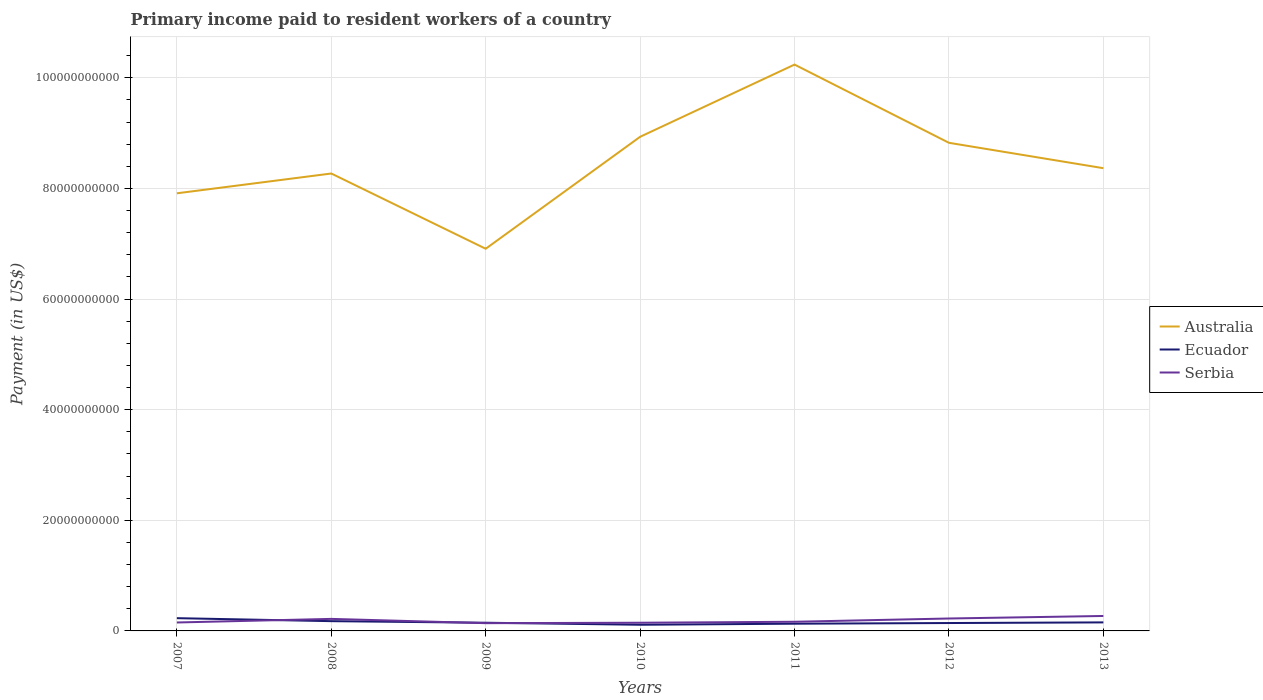How many different coloured lines are there?
Give a very brief answer. 3. Is the number of lines equal to the number of legend labels?
Provide a short and direct response. Yes. Across all years, what is the maximum amount paid to workers in Australia?
Offer a terse response. 6.91e+1. In which year was the amount paid to workers in Serbia maximum?
Ensure brevity in your answer.  2009. What is the total amount paid to workers in Ecuador in the graph?
Keep it short and to the point. -4.25e+08. What is the difference between the highest and the second highest amount paid to workers in Australia?
Your answer should be compact. 3.33e+1. What is the difference between the highest and the lowest amount paid to workers in Australia?
Your answer should be very brief. 3. Are the values on the major ticks of Y-axis written in scientific E-notation?
Ensure brevity in your answer.  No. Does the graph contain grids?
Give a very brief answer. Yes. How many legend labels are there?
Offer a very short reply. 3. How are the legend labels stacked?
Ensure brevity in your answer.  Vertical. What is the title of the graph?
Offer a very short reply. Primary income paid to resident workers of a country. What is the label or title of the Y-axis?
Offer a very short reply. Payment (in US$). What is the Payment (in US$) in Australia in 2007?
Your response must be concise. 7.91e+1. What is the Payment (in US$) in Ecuador in 2007?
Keep it short and to the point. 2.31e+09. What is the Payment (in US$) of Serbia in 2007?
Your response must be concise. 1.53e+09. What is the Payment (in US$) of Australia in 2008?
Your answer should be compact. 8.27e+1. What is the Payment (in US$) of Ecuador in 2008?
Give a very brief answer. 1.77e+09. What is the Payment (in US$) in Serbia in 2008?
Your answer should be compact. 2.18e+09. What is the Payment (in US$) of Australia in 2009?
Your answer should be compact. 6.91e+1. What is the Payment (in US$) in Ecuador in 2009?
Offer a very short reply. 1.48e+09. What is the Payment (in US$) in Serbia in 2009?
Provide a short and direct response. 1.40e+09. What is the Payment (in US$) of Australia in 2010?
Your answer should be compact. 8.93e+1. What is the Payment (in US$) in Ecuador in 2010?
Your answer should be compact. 1.12e+09. What is the Payment (in US$) in Serbia in 2010?
Keep it short and to the point. 1.48e+09. What is the Payment (in US$) in Australia in 2011?
Provide a short and direct response. 1.02e+11. What is the Payment (in US$) of Ecuador in 2011?
Provide a short and direct response. 1.30e+09. What is the Payment (in US$) of Serbia in 2011?
Ensure brevity in your answer.  1.65e+09. What is the Payment (in US$) of Australia in 2012?
Your answer should be compact. 8.83e+1. What is the Payment (in US$) of Ecuador in 2012?
Offer a terse response. 1.43e+09. What is the Payment (in US$) in Serbia in 2012?
Ensure brevity in your answer.  2.24e+09. What is the Payment (in US$) of Australia in 2013?
Provide a short and direct response. 8.37e+1. What is the Payment (in US$) in Ecuador in 2013?
Provide a succinct answer. 1.54e+09. What is the Payment (in US$) in Serbia in 2013?
Offer a terse response. 2.70e+09. Across all years, what is the maximum Payment (in US$) of Australia?
Provide a short and direct response. 1.02e+11. Across all years, what is the maximum Payment (in US$) in Ecuador?
Your answer should be very brief. 2.31e+09. Across all years, what is the maximum Payment (in US$) of Serbia?
Keep it short and to the point. 2.70e+09. Across all years, what is the minimum Payment (in US$) of Australia?
Provide a short and direct response. 6.91e+1. Across all years, what is the minimum Payment (in US$) in Ecuador?
Your response must be concise. 1.12e+09. Across all years, what is the minimum Payment (in US$) of Serbia?
Offer a terse response. 1.40e+09. What is the total Payment (in US$) of Australia in the graph?
Make the answer very short. 5.95e+11. What is the total Payment (in US$) in Ecuador in the graph?
Offer a terse response. 1.09e+1. What is the total Payment (in US$) in Serbia in the graph?
Provide a succinct answer. 1.32e+1. What is the difference between the Payment (in US$) of Australia in 2007 and that in 2008?
Make the answer very short. -3.58e+09. What is the difference between the Payment (in US$) in Ecuador in 2007 and that in 2008?
Give a very brief answer. 5.40e+08. What is the difference between the Payment (in US$) in Serbia in 2007 and that in 2008?
Ensure brevity in your answer.  -6.50e+08. What is the difference between the Payment (in US$) in Australia in 2007 and that in 2009?
Offer a terse response. 1.00e+1. What is the difference between the Payment (in US$) of Ecuador in 2007 and that in 2009?
Offer a very short reply. 8.27e+08. What is the difference between the Payment (in US$) in Serbia in 2007 and that in 2009?
Make the answer very short. 1.25e+08. What is the difference between the Payment (in US$) of Australia in 2007 and that in 2010?
Your answer should be very brief. -1.02e+1. What is the difference between the Payment (in US$) of Ecuador in 2007 and that in 2010?
Offer a terse response. 1.19e+09. What is the difference between the Payment (in US$) in Serbia in 2007 and that in 2010?
Provide a short and direct response. 4.60e+07. What is the difference between the Payment (in US$) of Australia in 2007 and that in 2011?
Make the answer very short. -2.33e+1. What is the difference between the Payment (in US$) of Ecuador in 2007 and that in 2011?
Offer a very short reply. 1.00e+09. What is the difference between the Payment (in US$) of Serbia in 2007 and that in 2011?
Your response must be concise. -1.29e+08. What is the difference between the Payment (in US$) of Australia in 2007 and that in 2012?
Provide a short and direct response. -9.13e+09. What is the difference between the Payment (in US$) of Ecuador in 2007 and that in 2012?
Ensure brevity in your answer.  8.78e+08. What is the difference between the Payment (in US$) in Serbia in 2007 and that in 2012?
Offer a terse response. -7.19e+08. What is the difference between the Payment (in US$) in Australia in 2007 and that in 2013?
Make the answer very short. -4.54e+09. What is the difference between the Payment (in US$) of Ecuador in 2007 and that in 2013?
Keep it short and to the point. 7.64e+08. What is the difference between the Payment (in US$) in Serbia in 2007 and that in 2013?
Offer a terse response. -1.18e+09. What is the difference between the Payment (in US$) in Australia in 2008 and that in 2009?
Ensure brevity in your answer.  1.36e+1. What is the difference between the Payment (in US$) of Ecuador in 2008 and that in 2009?
Give a very brief answer. 2.87e+08. What is the difference between the Payment (in US$) of Serbia in 2008 and that in 2009?
Your answer should be compact. 7.74e+08. What is the difference between the Payment (in US$) in Australia in 2008 and that in 2010?
Give a very brief answer. -6.64e+09. What is the difference between the Payment (in US$) of Ecuador in 2008 and that in 2010?
Give a very brief answer. 6.50e+08. What is the difference between the Payment (in US$) in Serbia in 2008 and that in 2010?
Provide a succinct answer. 6.96e+08. What is the difference between the Payment (in US$) of Australia in 2008 and that in 2011?
Your answer should be very brief. -1.97e+1. What is the difference between the Payment (in US$) of Ecuador in 2008 and that in 2011?
Provide a succinct answer. 4.61e+08. What is the difference between the Payment (in US$) of Serbia in 2008 and that in 2011?
Your response must be concise. 5.21e+08. What is the difference between the Payment (in US$) in Australia in 2008 and that in 2012?
Offer a terse response. -5.55e+09. What is the difference between the Payment (in US$) in Ecuador in 2008 and that in 2012?
Give a very brief answer. 3.38e+08. What is the difference between the Payment (in US$) in Serbia in 2008 and that in 2012?
Give a very brief answer. -6.90e+07. What is the difference between the Payment (in US$) in Australia in 2008 and that in 2013?
Give a very brief answer. -9.62e+08. What is the difference between the Payment (in US$) of Ecuador in 2008 and that in 2013?
Keep it short and to the point. 2.25e+08. What is the difference between the Payment (in US$) in Serbia in 2008 and that in 2013?
Your answer should be very brief. -5.28e+08. What is the difference between the Payment (in US$) of Australia in 2009 and that in 2010?
Your answer should be compact. -2.02e+1. What is the difference between the Payment (in US$) in Ecuador in 2009 and that in 2010?
Provide a succinct answer. 3.63e+08. What is the difference between the Payment (in US$) in Serbia in 2009 and that in 2010?
Make the answer very short. -7.85e+07. What is the difference between the Payment (in US$) in Australia in 2009 and that in 2011?
Offer a very short reply. -3.33e+1. What is the difference between the Payment (in US$) of Ecuador in 2009 and that in 2011?
Ensure brevity in your answer.  1.74e+08. What is the difference between the Payment (in US$) of Serbia in 2009 and that in 2011?
Provide a short and direct response. -2.54e+08. What is the difference between the Payment (in US$) of Australia in 2009 and that in 2012?
Offer a very short reply. -1.92e+1. What is the difference between the Payment (in US$) in Ecuador in 2009 and that in 2012?
Your response must be concise. 5.15e+07. What is the difference between the Payment (in US$) in Serbia in 2009 and that in 2012?
Your answer should be very brief. -8.43e+08. What is the difference between the Payment (in US$) in Australia in 2009 and that in 2013?
Make the answer very short. -1.46e+1. What is the difference between the Payment (in US$) in Ecuador in 2009 and that in 2013?
Offer a terse response. -6.24e+07. What is the difference between the Payment (in US$) in Serbia in 2009 and that in 2013?
Your response must be concise. -1.30e+09. What is the difference between the Payment (in US$) of Australia in 2010 and that in 2011?
Provide a short and direct response. -1.31e+1. What is the difference between the Payment (in US$) in Ecuador in 2010 and that in 2011?
Your answer should be very brief. -1.88e+08. What is the difference between the Payment (in US$) of Serbia in 2010 and that in 2011?
Offer a very short reply. -1.75e+08. What is the difference between the Payment (in US$) of Australia in 2010 and that in 2012?
Your response must be concise. 1.09e+09. What is the difference between the Payment (in US$) in Ecuador in 2010 and that in 2012?
Give a very brief answer. -3.11e+08. What is the difference between the Payment (in US$) of Serbia in 2010 and that in 2012?
Offer a very short reply. -7.65e+08. What is the difference between the Payment (in US$) in Australia in 2010 and that in 2013?
Your response must be concise. 5.68e+09. What is the difference between the Payment (in US$) in Ecuador in 2010 and that in 2013?
Ensure brevity in your answer.  -4.25e+08. What is the difference between the Payment (in US$) of Serbia in 2010 and that in 2013?
Keep it short and to the point. -1.22e+09. What is the difference between the Payment (in US$) of Australia in 2011 and that in 2012?
Offer a very short reply. 1.41e+1. What is the difference between the Payment (in US$) in Ecuador in 2011 and that in 2012?
Offer a very short reply. -1.23e+08. What is the difference between the Payment (in US$) of Serbia in 2011 and that in 2012?
Offer a very short reply. -5.90e+08. What is the difference between the Payment (in US$) of Australia in 2011 and that in 2013?
Keep it short and to the point. 1.87e+1. What is the difference between the Payment (in US$) in Ecuador in 2011 and that in 2013?
Provide a succinct answer. -2.37e+08. What is the difference between the Payment (in US$) in Serbia in 2011 and that in 2013?
Make the answer very short. -1.05e+09. What is the difference between the Payment (in US$) in Australia in 2012 and that in 2013?
Your answer should be very brief. 4.59e+09. What is the difference between the Payment (in US$) in Ecuador in 2012 and that in 2013?
Make the answer very short. -1.14e+08. What is the difference between the Payment (in US$) of Serbia in 2012 and that in 2013?
Provide a short and direct response. -4.59e+08. What is the difference between the Payment (in US$) in Australia in 2007 and the Payment (in US$) in Ecuador in 2008?
Provide a succinct answer. 7.74e+1. What is the difference between the Payment (in US$) of Australia in 2007 and the Payment (in US$) of Serbia in 2008?
Offer a very short reply. 7.69e+1. What is the difference between the Payment (in US$) of Ecuador in 2007 and the Payment (in US$) of Serbia in 2008?
Offer a very short reply. 1.30e+08. What is the difference between the Payment (in US$) in Australia in 2007 and the Payment (in US$) in Ecuador in 2009?
Offer a terse response. 7.76e+1. What is the difference between the Payment (in US$) of Australia in 2007 and the Payment (in US$) of Serbia in 2009?
Offer a very short reply. 7.77e+1. What is the difference between the Payment (in US$) in Ecuador in 2007 and the Payment (in US$) in Serbia in 2009?
Your answer should be compact. 9.04e+08. What is the difference between the Payment (in US$) in Australia in 2007 and the Payment (in US$) in Ecuador in 2010?
Provide a succinct answer. 7.80e+1. What is the difference between the Payment (in US$) of Australia in 2007 and the Payment (in US$) of Serbia in 2010?
Keep it short and to the point. 7.76e+1. What is the difference between the Payment (in US$) of Ecuador in 2007 and the Payment (in US$) of Serbia in 2010?
Provide a short and direct response. 8.26e+08. What is the difference between the Payment (in US$) of Australia in 2007 and the Payment (in US$) of Ecuador in 2011?
Offer a terse response. 7.78e+1. What is the difference between the Payment (in US$) of Australia in 2007 and the Payment (in US$) of Serbia in 2011?
Your response must be concise. 7.75e+1. What is the difference between the Payment (in US$) in Ecuador in 2007 and the Payment (in US$) in Serbia in 2011?
Your answer should be compact. 6.51e+08. What is the difference between the Payment (in US$) of Australia in 2007 and the Payment (in US$) of Ecuador in 2012?
Provide a succinct answer. 7.77e+1. What is the difference between the Payment (in US$) of Australia in 2007 and the Payment (in US$) of Serbia in 2012?
Your answer should be very brief. 7.69e+1. What is the difference between the Payment (in US$) of Ecuador in 2007 and the Payment (in US$) of Serbia in 2012?
Your answer should be compact. 6.09e+07. What is the difference between the Payment (in US$) of Australia in 2007 and the Payment (in US$) of Ecuador in 2013?
Keep it short and to the point. 7.76e+1. What is the difference between the Payment (in US$) of Australia in 2007 and the Payment (in US$) of Serbia in 2013?
Ensure brevity in your answer.  7.64e+1. What is the difference between the Payment (in US$) in Ecuador in 2007 and the Payment (in US$) in Serbia in 2013?
Offer a very short reply. -3.98e+08. What is the difference between the Payment (in US$) of Australia in 2008 and the Payment (in US$) of Ecuador in 2009?
Your answer should be very brief. 8.12e+1. What is the difference between the Payment (in US$) in Australia in 2008 and the Payment (in US$) in Serbia in 2009?
Ensure brevity in your answer.  8.13e+1. What is the difference between the Payment (in US$) in Ecuador in 2008 and the Payment (in US$) in Serbia in 2009?
Ensure brevity in your answer.  3.65e+08. What is the difference between the Payment (in US$) of Australia in 2008 and the Payment (in US$) of Ecuador in 2010?
Offer a very short reply. 8.16e+1. What is the difference between the Payment (in US$) in Australia in 2008 and the Payment (in US$) in Serbia in 2010?
Keep it short and to the point. 8.12e+1. What is the difference between the Payment (in US$) of Ecuador in 2008 and the Payment (in US$) of Serbia in 2010?
Offer a terse response. 2.86e+08. What is the difference between the Payment (in US$) of Australia in 2008 and the Payment (in US$) of Ecuador in 2011?
Offer a very short reply. 8.14e+1. What is the difference between the Payment (in US$) of Australia in 2008 and the Payment (in US$) of Serbia in 2011?
Provide a succinct answer. 8.11e+1. What is the difference between the Payment (in US$) in Ecuador in 2008 and the Payment (in US$) in Serbia in 2011?
Your answer should be very brief. 1.11e+08. What is the difference between the Payment (in US$) in Australia in 2008 and the Payment (in US$) in Ecuador in 2012?
Ensure brevity in your answer.  8.13e+1. What is the difference between the Payment (in US$) in Australia in 2008 and the Payment (in US$) in Serbia in 2012?
Give a very brief answer. 8.05e+1. What is the difference between the Payment (in US$) in Ecuador in 2008 and the Payment (in US$) in Serbia in 2012?
Give a very brief answer. -4.79e+08. What is the difference between the Payment (in US$) in Australia in 2008 and the Payment (in US$) in Ecuador in 2013?
Give a very brief answer. 8.12e+1. What is the difference between the Payment (in US$) of Australia in 2008 and the Payment (in US$) of Serbia in 2013?
Offer a terse response. 8.00e+1. What is the difference between the Payment (in US$) in Ecuador in 2008 and the Payment (in US$) in Serbia in 2013?
Keep it short and to the point. -9.37e+08. What is the difference between the Payment (in US$) in Australia in 2009 and the Payment (in US$) in Ecuador in 2010?
Make the answer very short. 6.80e+1. What is the difference between the Payment (in US$) in Australia in 2009 and the Payment (in US$) in Serbia in 2010?
Ensure brevity in your answer.  6.76e+1. What is the difference between the Payment (in US$) in Ecuador in 2009 and the Payment (in US$) in Serbia in 2010?
Keep it short and to the point. -9.51e+05. What is the difference between the Payment (in US$) of Australia in 2009 and the Payment (in US$) of Ecuador in 2011?
Provide a succinct answer. 6.78e+1. What is the difference between the Payment (in US$) in Australia in 2009 and the Payment (in US$) in Serbia in 2011?
Your answer should be compact. 6.74e+1. What is the difference between the Payment (in US$) in Ecuador in 2009 and the Payment (in US$) in Serbia in 2011?
Make the answer very short. -1.76e+08. What is the difference between the Payment (in US$) in Australia in 2009 and the Payment (in US$) in Ecuador in 2012?
Provide a succinct answer. 6.77e+1. What is the difference between the Payment (in US$) in Australia in 2009 and the Payment (in US$) in Serbia in 2012?
Your answer should be compact. 6.69e+1. What is the difference between the Payment (in US$) of Ecuador in 2009 and the Payment (in US$) of Serbia in 2012?
Ensure brevity in your answer.  -7.66e+08. What is the difference between the Payment (in US$) of Australia in 2009 and the Payment (in US$) of Ecuador in 2013?
Offer a very short reply. 6.76e+1. What is the difference between the Payment (in US$) in Australia in 2009 and the Payment (in US$) in Serbia in 2013?
Provide a succinct answer. 6.64e+1. What is the difference between the Payment (in US$) in Ecuador in 2009 and the Payment (in US$) in Serbia in 2013?
Ensure brevity in your answer.  -1.22e+09. What is the difference between the Payment (in US$) of Australia in 2010 and the Payment (in US$) of Ecuador in 2011?
Provide a succinct answer. 8.80e+1. What is the difference between the Payment (in US$) in Australia in 2010 and the Payment (in US$) in Serbia in 2011?
Make the answer very short. 8.77e+1. What is the difference between the Payment (in US$) of Ecuador in 2010 and the Payment (in US$) of Serbia in 2011?
Offer a very short reply. -5.39e+08. What is the difference between the Payment (in US$) of Australia in 2010 and the Payment (in US$) of Ecuador in 2012?
Offer a very short reply. 8.79e+1. What is the difference between the Payment (in US$) in Australia in 2010 and the Payment (in US$) in Serbia in 2012?
Provide a succinct answer. 8.71e+1. What is the difference between the Payment (in US$) in Ecuador in 2010 and the Payment (in US$) in Serbia in 2012?
Provide a short and direct response. -1.13e+09. What is the difference between the Payment (in US$) of Australia in 2010 and the Payment (in US$) of Ecuador in 2013?
Your answer should be compact. 8.78e+1. What is the difference between the Payment (in US$) of Australia in 2010 and the Payment (in US$) of Serbia in 2013?
Your answer should be compact. 8.66e+1. What is the difference between the Payment (in US$) of Ecuador in 2010 and the Payment (in US$) of Serbia in 2013?
Provide a succinct answer. -1.59e+09. What is the difference between the Payment (in US$) in Australia in 2011 and the Payment (in US$) in Ecuador in 2012?
Ensure brevity in your answer.  1.01e+11. What is the difference between the Payment (in US$) of Australia in 2011 and the Payment (in US$) of Serbia in 2012?
Ensure brevity in your answer.  1.00e+11. What is the difference between the Payment (in US$) of Ecuador in 2011 and the Payment (in US$) of Serbia in 2012?
Provide a succinct answer. -9.40e+08. What is the difference between the Payment (in US$) in Australia in 2011 and the Payment (in US$) in Ecuador in 2013?
Provide a short and direct response. 1.01e+11. What is the difference between the Payment (in US$) in Australia in 2011 and the Payment (in US$) in Serbia in 2013?
Offer a terse response. 9.97e+1. What is the difference between the Payment (in US$) in Ecuador in 2011 and the Payment (in US$) in Serbia in 2013?
Ensure brevity in your answer.  -1.40e+09. What is the difference between the Payment (in US$) in Australia in 2012 and the Payment (in US$) in Ecuador in 2013?
Make the answer very short. 8.67e+1. What is the difference between the Payment (in US$) in Australia in 2012 and the Payment (in US$) in Serbia in 2013?
Give a very brief answer. 8.56e+1. What is the difference between the Payment (in US$) in Ecuador in 2012 and the Payment (in US$) in Serbia in 2013?
Offer a very short reply. -1.28e+09. What is the average Payment (in US$) in Australia per year?
Your answer should be compact. 8.49e+1. What is the average Payment (in US$) of Ecuador per year?
Keep it short and to the point. 1.56e+09. What is the average Payment (in US$) in Serbia per year?
Make the answer very short. 1.88e+09. In the year 2007, what is the difference between the Payment (in US$) of Australia and Payment (in US$) of Ecuador?
Provide a succinct answer. 7.68e+1. In the year 2007, what is the difference between the Payment (in US$) of Australia and Payment (in US$) of Serbia?
Provide a short and direct response. 7.76e+1. In the year 2007, what is the difference between the Payment (in US$) of Ecuador and Payment (in US$) of Serbia?
Your answer should be very brief. 7.80e+08. In the year 2008, what is the difference between the Payment (in US$) of Australia and Payment (in US$) of Ecuador?
Provide a short and direct response. 8.09e+1. In the year 2008, what is the difference between the Payment (in US$) of Australia and Payment (in US$) of Serbia?
Your answer should be very brief. 8.05e+1. In the year 2008, what is the difference between the Payment (in US$) in Ecuador and Payment (in US$) in Serbia?
Ensure brevity in your answer.  -4.10e+08. In the year 2009, what is the difference between the Payment (in US$) in Australia and Payment (in US$) in Ecuador?
Your answer should be very brief. 6.76e+1. In the year 2009, what is the difference between the Payment (in US$) in Australia and Payment (in US$) in Serbia?
Your response must be concise. 6.77e+1. In the year 2009, what is the difference between the Payment (in US$) in Ecuador and Payment (in US$) in Serbia?
Your response must be concise. 7.76e+07. In the year 2010, what is the difference between the Payment (in US$) in Australia and Payment (in US$) in Ecuador?
Ensure brevity in your answer.  8.82e+1. In the year 2010, what is the difference between the Payment (in US$) in Australia and Payment (in US$) in Serbia?
Offer a terse response. 8.79e+1. In the year 2010, what is the difference between the Payment (in US$) in Ecuador and Payment (in US$) in Serbia?
Your answer should be very brief. -3.64e+08. In the year 2011, what is the difference between the Payment (in US$) of Australia and Payment (in US$) of Ecuador?
Keep it short and to the point. 1.01e+11. In the year 2011, what is the difference between the Payment (in US$) of Australia and Payment (in US$) of Serbia?
Your response must be concise. 1.01e+11. In the year 2011, what is the difference between the Payment (in US$) in Ecuador and Payment (in US$) in Serbia?
Ensure brevity in your answer.  -3.50e+08. In the year 2012, what is the difference between the Payment (in US$) of Australia and Payment (in US$) of Ecuador?
Offer a very short reply. 8.68e+1. In the year 2012, what is the difference between the Payment (in US$) of Australia and Payment (in US$) of Serbia?
Provide a short and direct response. 8.60e+1. In the year 2012, what is the difference between the Payment (in US$) of Ecuador and Payment (in US$) of Serbia?
Offer a terse response. -8.17e+08. In the year 2013, what is the difference between the Payment (in US$) in Australia and Payment (in US$) in Ecuador?
Provide a short and direct response. 8.21e+1. In the year 2013, what is the difference between the Payment (in US$) of Australia and Payment (in US$) of Serbia?
Offer a terse response. 8.10e+1. In the year 2013, what is the difference between the Payment (in US$) in Ecuador and Payment (in US$) in Serbia?
Give a very brief answer. -1.16e+09. What is the ratio of the Payment (in US$) in Australia in 2007 to that in 2008?
Your answer should be compact. 0.96. What is the ratio of the Payment (in US$) of Ecuador in 2007 to that in 2008?
Make the answer very short. 1.31. What is the ratio of the Payment (in US$) in Serbia in 2007 to that in 2008?
Make the answer very short. 0.7. What is the ratio of the Payment (in US$) in Australia in 2007 to that in 2009?
Your answer should be very brief. 1.15. What is the ratio of the Payment (in US$) of Ecuador in 2007 to that in 2009?
Give a very brief answer. 1.56. What is the ratio of the Payment (in US$) of Serbia in 2007 to that in 2009?
Offer a terse response. 1.09. What is the ratio of the Payment (in US$) in Australia in 2007 to that in 2010?
Your answer should be very brief. 0.89. What is the ratio of the Payment (in US$) of Ecuador in 2007 to that in 2010?
Keep it short and to the point. 2.07. What is the ratio of the Payment (in US$) in Serbia in 2007 to that in 2010?
Your answer should be compact. 1.03. What is the ratio of the Payment (in US$) in Australia in 2007 to that in 2011?
Offer a terse response. 0.77. What is the ratio of the Payment (in US$) in Ecuador in 2007 to that in 2011?
Ensure brevity in your answer.  1.77. What is the ratio of the Payment (in US$) of Serbia in 2007 to that in 2011?
Give a very brief answer. 0.92. What is the ratio of the Payment (in US$) of Australia in 2007 to that in 2012?
Ensure brevity in your answer.  0.9. What is the ratio of the Payment (in US$) in Ecuador in 2007 to that in 2012?
Keep it short and to the point. 1.62. What is the ratio of the Payment (in US$) in Serbia in 2007 to that in 2012?
Provide a short and direct response. 0.68. What is the ratio of the Payment (in US$) in Australia in 2007 to that in 2013?
Keep it short and to the point. 0.95. What is the ratio of the Payment (in US$) in Ecuador in 2007 to that in 2013?
Offer a terse response. 1.5. What is the ratio of the Payment (in US$) of Serbia in 2007 to that in 2013?
Keep it short and to the point. 0.56. What is the ratio of the Payment (in US$) in Australia in 2008 to that in 2009?
Give a very brief answer. 1.2. What is the ratio of the Payment (in US$) in Ecuador in 2008 to that in 2009?
Your answer should be compact. 1.19. What is the ratio of the Payment (in US$) in Serbia in 2008 to that in 2009?
Keep it short and to the point. 1.55. What is the ratio of the Payment (in US$) of Australia in 2008 to that in 2010?
Keep it short and to the point. 0.93. What is the ratio of the Payment (in US$) of Ecuador in 2008 to that in 2010?
Ensure brevity in your answer.  1.58. What is the ratio of the Payment (in US$) in Serbia in 2008 to that in 2010?
Your answer should be compact. 1.47. What is the ratio of the Payment (in US$) in Australia in 2008 to that in 2011?
Offer a very short reply. 0.81. What is the ratio of the Payment (in US$) in Ecuador in 2008 to that in 2011?
Keep it short and to the point. 1.35. What is the ratio of the Payment (in US$) in Serbia in 2008 to that in 2011?
Keep it short and to the point. 1.31. What is the ratio of the Payment (in US$) of Australia in 2008 to that in 2012?
Your answer should be very brief. 0.94. What is the ratio of the Payment (in US$) of Ecuador in 2008 to that in 2012?
Your answer should be very brief. 1.24. What is the ratio of the Payment (in US$) of Serbia in 2008 to that in 2012?
Provide a succinct answer. 0.97. What is the ratio of the Payment (in US$) in Ecuador in 2008 to that in 2013?
Your response must be concise. 1.15. What is the ratio of the Payment (in US$) in Serbia in 2008 to that in 2013?
Give a very brief answer. 0.8. What is the ratio of the Payment (in US$) of Australia in 2009 to that in 2010?
Your answer should be compact. 0.77. What is the ratio of the Payment (in US$) in Ecuador in 2009 to that in 2010?
Ensure brevity in your answer.  1.32. What is the ratio of the Payment (in US$) in Serbia in 2009 to that in 2010?
Provide a short and direct response. 0.95. What is the ratio of the Payment (in US$) of Australia in 2009 to that in 2011?
Provide a succinct answer. 0.67. What is the ratio of the Payment (in US$) of Ecuador in 2009 to that in 2011?
Your answer should be compact. 1.13. What is the ratio of the Payment (in US$) in Serbia in 2009 to that in 2011?
Your answer should be very brief. 0.85. What is the ratio of the Payment (in US$) of Australia in 2009 to that in 2012?
Provide a short and direct response. 0.78. What is the ratio of the Payment (in US$) in Ecuador in 2009 to that in 2012?
Provide a short and direct response. 1.04. What is the ratio of the Payment (in US$) of Serbia in 2009 to that in 2012?
Your answer should be very brief. 0.62. What is the ratio of the Payment (in US$) of Australia in 2009 to that in 2013?
Offer a terse response. 0.83. What is the ratio of the Payment (in US$) in Ecuador in 2009 to that in 2013?
Offer a terse response. 0.96. What is the ratio of the Payment (in US$) in Serbia in 2009 to that in 2013?
Offer a terse response. 0.52. What is the ratio of the Payment (in US$) of Australia in 2010 to that in 2011?
Make the answer very short. 0.87. What is the ratio of the Payment (in US$) of Ecuador in 2010 to that in 2011?
Provide a short and direct response. 0.86. What is the ratio of the Payment (in US$) of Serbia in 2010 to that in 2011?
Offer a very short reply. 0.89. What is the ratio of the Payment (in US$) in Australia in 2010 to that in 2012?
Give a very brief answer. 1.01. What is the ratio of the Payment (in US$) of Ecuador in 2010 to that in 2012?
Give a very brief answer. 0.78. What is the ratio of the Payment (in US$) in Serbia in 2010 to that in 2012?
Give a very brief answer. 0.66. What is the ratio of the Payment (in US$) in Australia in 2010 to that in 2013?
Your response must be concise. 1.07. What is the ratio of the Payment (in US$) in Ecuador in 2010 to that in 2013?
Keep it short and to the point. 0.72. What is the ratio of the Payment (in US$) of Serbia in 2010 to that in 2013?
Offer a terse response. 0.55. What is the ratio of the Payment (in US$) in Australia in 2011 to that in 2012?
Provide a succinct answer. 1.16. What is the ratio of the Payment (in US$) in Ecuador in 2011 to that in 2012?
Give a very brief answer. 0.91. What is the ratio of the Payment (in US$) in Serbia in 2011 to that in 2012?
Offer a terse response. 0.74. What is the ratio of the Payment (in US$) in Australia in 2011 to that in 2013?
Your answer should be very brief. 1.22. What is the ratio of the Payment (in US$) in Ecuador in 2011 to that in 2013?
Provide a short and direct response. 0.85. What is the ratio of the Payment (in US$) in Serbia in 2011 to that in 2013?
Offer a very short reply. 0.61. What is the ratio of the Payment (in US$) of Australia in 2012 to that in 2013?
Your answer should be compact. 1.05. What is the ratio of the Payment (in US$) in Ecuador in 2012 to that in 2013?
Keep it short and to the point. 0.93. What is the ratio of the Payment (in US$) in Serbia in 2012 to that in 2013?
Your response must be concise. 0.83. What is the difference between the highest and the second highest Payment (in US$) in Australia?
Offer a very short reply. 1.31e+1. What is the difference between the highest and the second highest Payment (in US$) in Ecuador?
Your response must be concise. 5.40e+08. What is the difference between the highest and the second highest Payment (in US$) of Serbia?
Offer a terse response. 4.59e+08. What is the difference between the highest and the lowest Payment (in US$) of Australia?
Give a very brief answer. 3.33e+1. What is the difference between the highest and the lowest Payment (in US$) of Ecuador?
Give a very brief answer. 1.19e+09. What is the difference between the highest and the lowest Payment (in US$) in Serbia?
Your answer should be compact. 1.30e+09. 